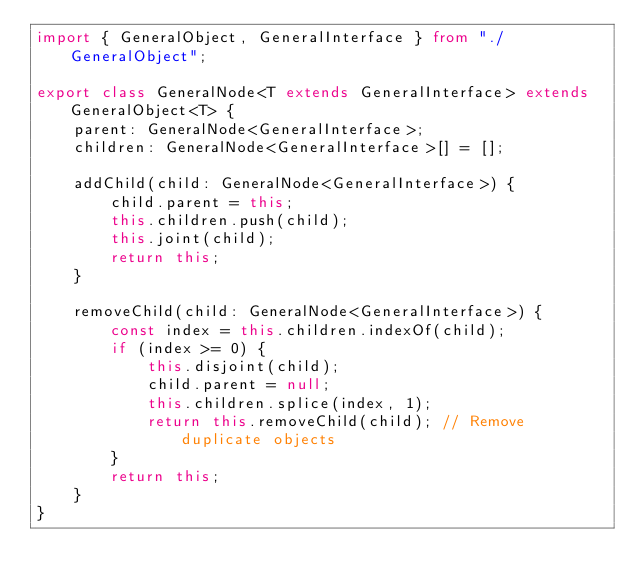<code> <loc_0><loc_0><loc_500><loc_500><_TypeScript_>import { GeneralObject, GeneralInterface } from "./GeneralObject";

export class GeneralNode<T extends GeneralInterface> extends GeneralObject<T> {
    parent: GeneralNode<GeneralInterface>;
    children: GeneralNode<GeneralInterface>[] = [];

    addChild(child: GeneralNode<GeneralInterface>) {
        child.parent = this;
        this.children.push(child);
        this.joint(child);
        return this;
    }

    removeChild(child: GeneralNode<GeneralInterface>) {
        const index = this.children.indexOf(child);
        if (index >= 0) {
            this.disjoint(child);
            child.parent = null;
            this.children.splice(index, 1);
            return this.removeChild(child); // Remove duplicate objects
        }
        return this;
    }
}
</code> 